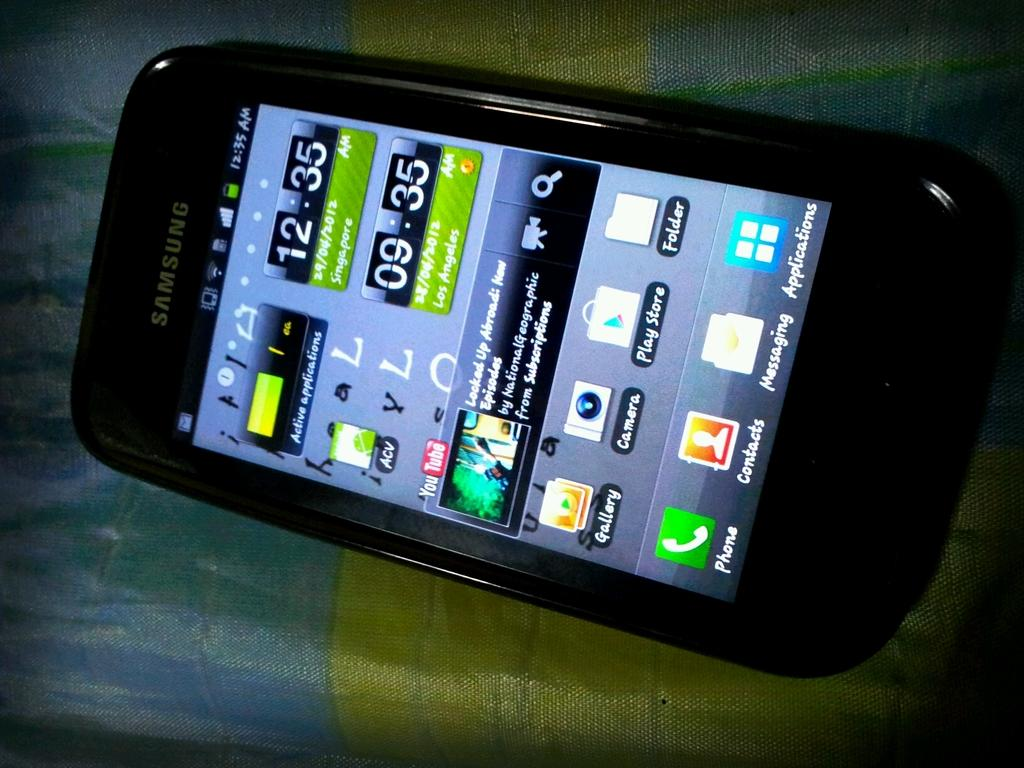<image>
Give a short and clear explanation of the subsequent image. The front screen of a samsung branded cell phone displaying icons for apps like the google play store. 